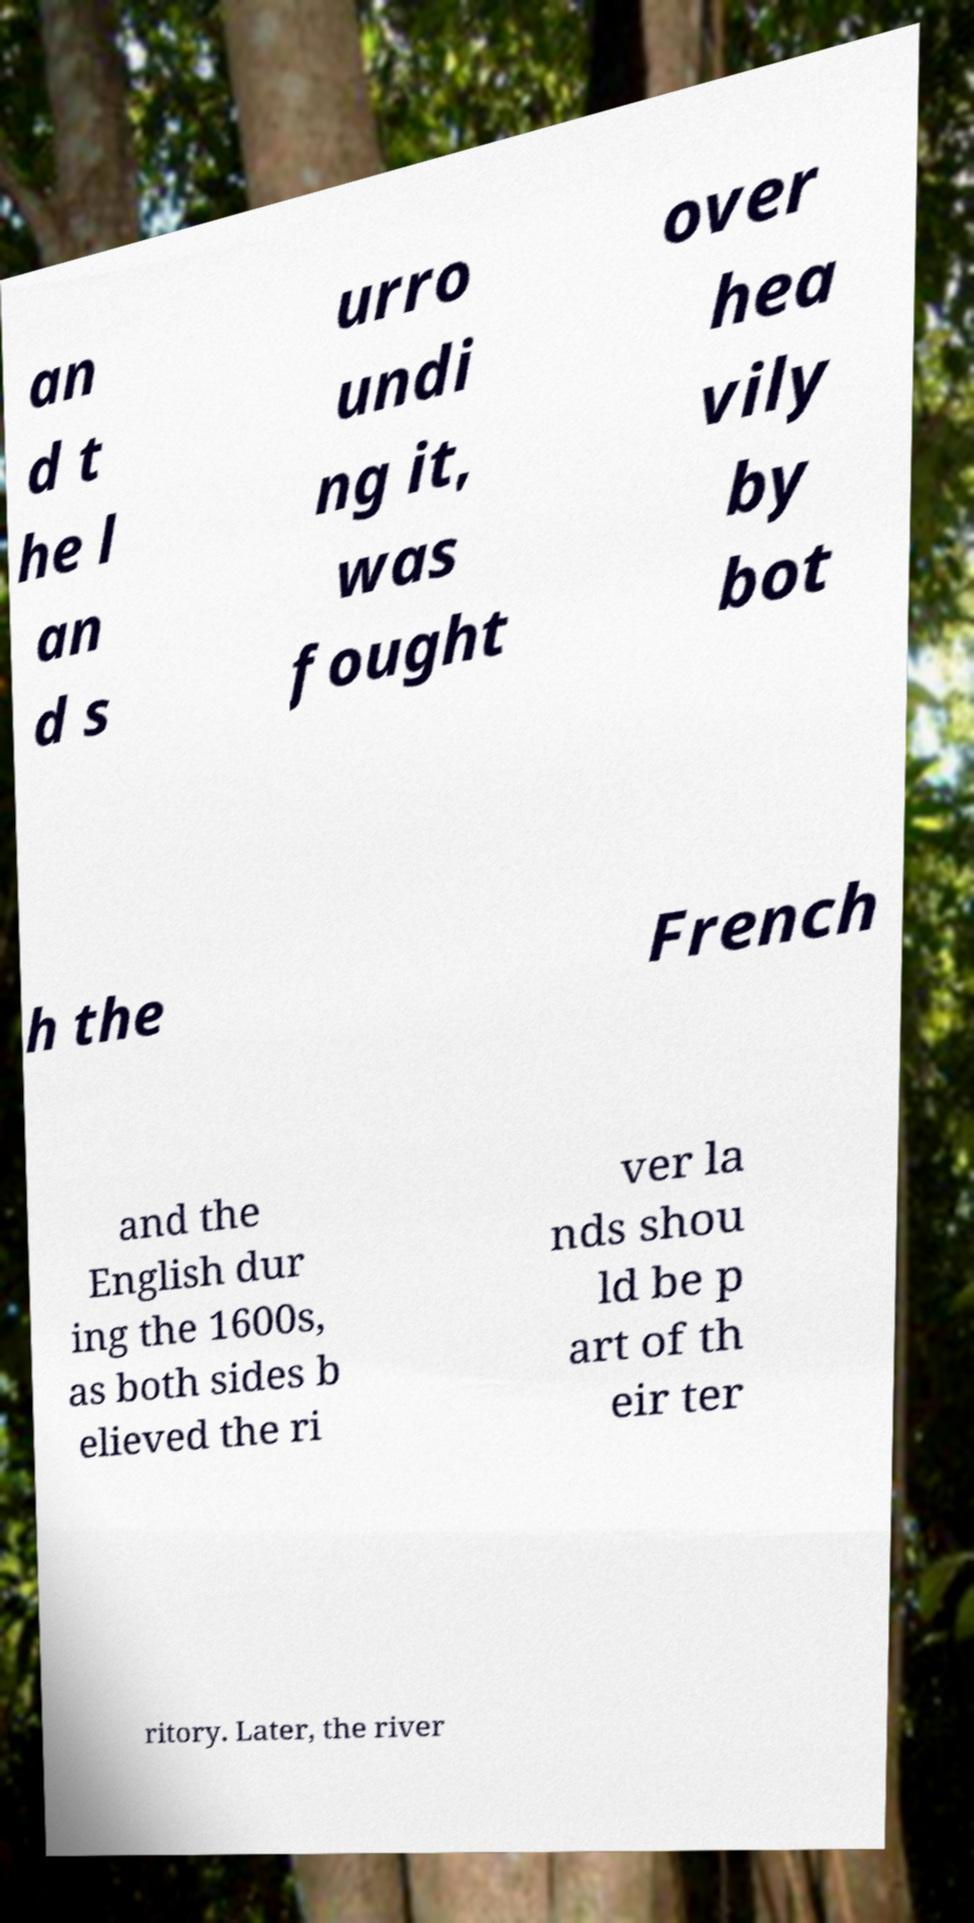Please read and relay the text visible in this image. What does it say? an d t he l an d s urro undi ng it, was fought over hea vily by bot h the French and the English dur ing the 1600s, as both sides b elieved the ri ver la nds shou ld be p art of th eir ter ritory. Later, the river 